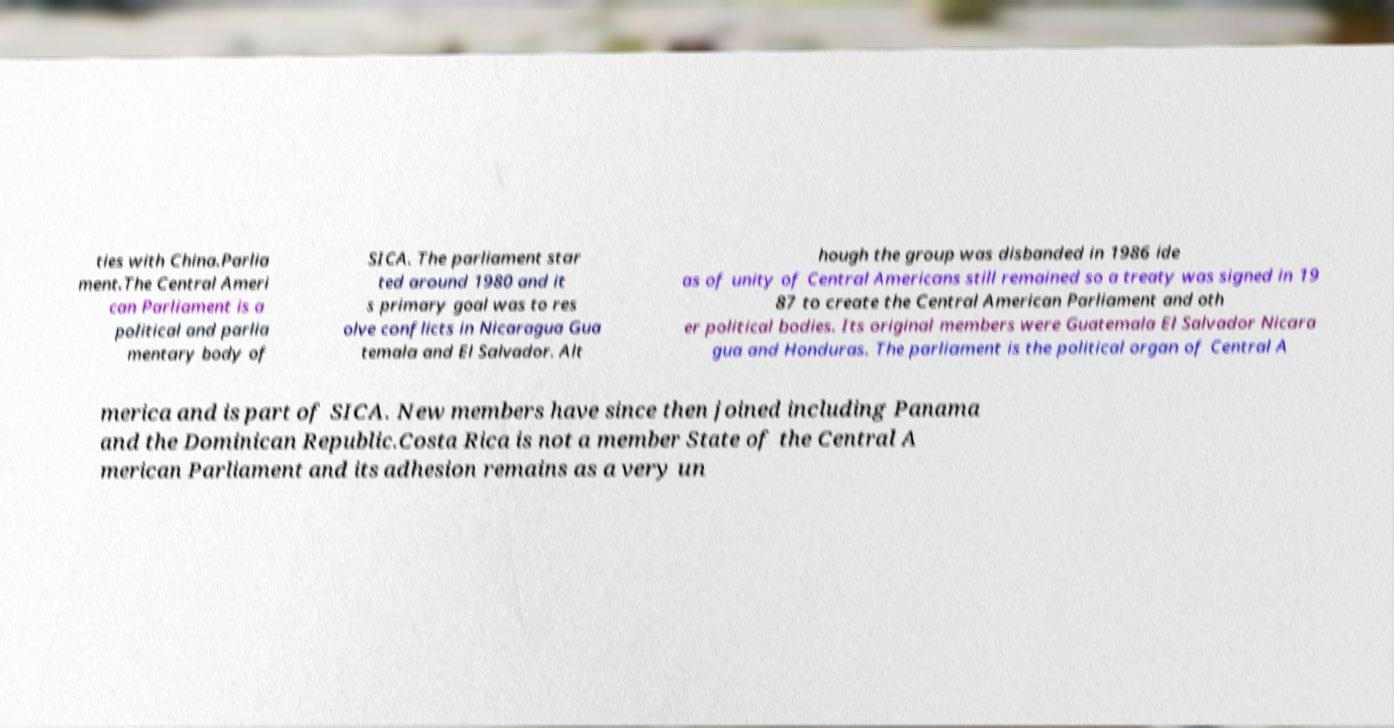There's text embedded in this image that I need extracted. Can you transcribe it verbatim? ties with China.Parlia ment.The Central Ameri can Parliament is a political and parlia mentary body of SICA. The parliament star ted around 1980 and it s primary goal was to res olve conflicts in Nicaragua Gua temala and El Salvador. Alt hough the group was disbanded in 1986 ide as of unity of Central Americans still remained so a treaty was signed in 19 87 to create the Central American Parliament and oth er political bodies. Its original members were Guatemala El Salvador Nicara gua and Honduras. The parliament is the political organ of Central A merica and is part of SICA. New members have since then joined including Panama and the Dominican Republic.Costa Rica is not a member State of the Central A merican Parliament and its adhesion remains as a very un 